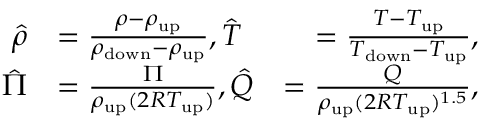<formula> <loc_0><loc_0><loc_500><loc_500>\begin{array} { r l r } { \hat { \rho } } & { = \frac { \rho - \rho _ { u p } } { \rho _ { d o w n } - \rho _ { u p } } , \hat { T } } & { = \frac { T - T _ { u p } } { T _ { d o w n } - T _ { u p } } , } \\ { \hat { \Pi } } & { = \frac { \Pi } { \rho _ { u p } ( 2 R T _ { u p } ) } , \hat { Q } } & { = \frac { Q } { \rho _ { u p } ( 2 R T _ { u p } ) ^ { 1 . 5 } } , } \end{array}</formula> 